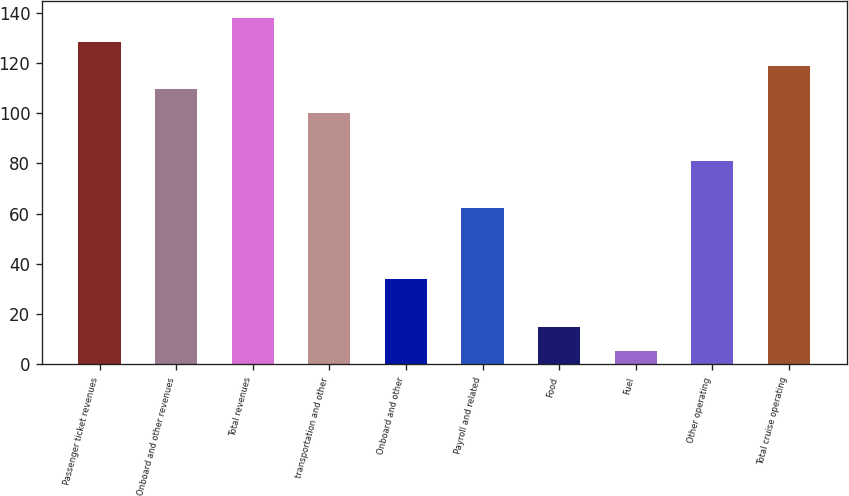<chart> <loc_0><loc_0><loc_500><loc_500><bar_chart><fcel>Passenger ticket revenues<fcel>Onboard and other revenues<fcel>Total revenues<fcel>transportation and other<fcel>Onboard and other<fcel>Payroll and related<fcel>Food<fcel>Fuel<fcel>Other operating<fcel>Total cruise operating<nl><fcel>128.35<fcel>109.45<fcel>137.8<fcel>100<fcel>33.85<fcel>62.2<fcel>14.95<fcel>5.5<fcel>81.1<fcel>118.9<nl></chart> 